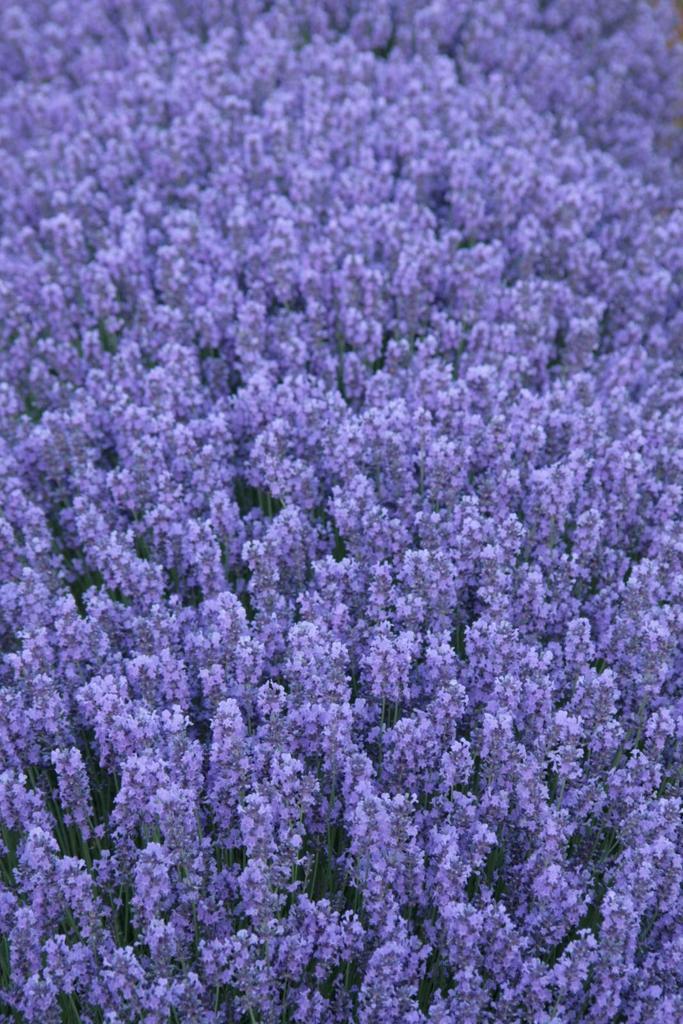Could you give a brief overview of what you see in this image? In this picture we can see some plants and leaves. 